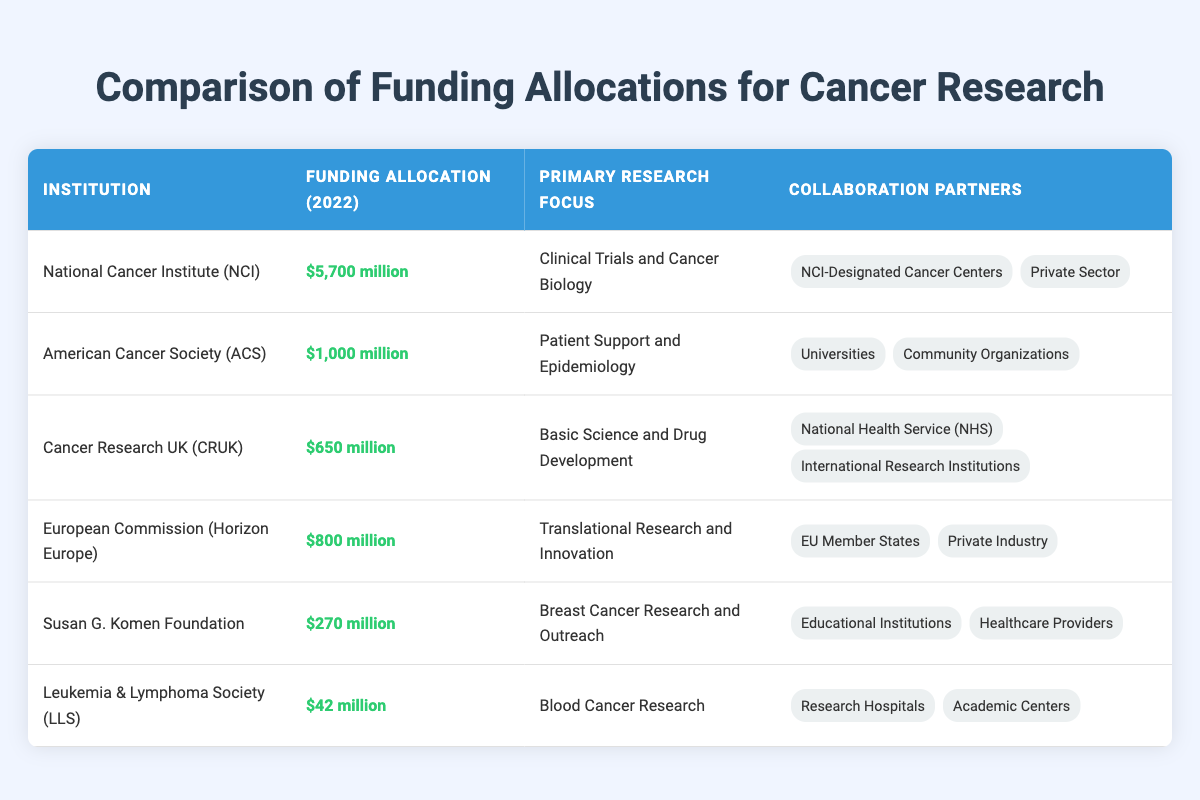What is the highest funding allocation among the institutions? The highest funding allocation can be found by comparing the values in the second column. The National Cancer Institute (NCI) has the highest amount of $5,700 million.
Answer: $5,700 million Which institution focuses on patient support and epidemiology? By looking at the third column of the table, the American Cancer Society (ACS) is listed with a primary research focus on patient support and epidemiology.
Answer: American Cancer Society (ACS) How much funding did Cancer Research UK (CRUK) receive in 2022? The funding allocation for Cancer Research UK (CRUK) is explicitly written in the table under the second column for the 2022 row, which is $650 million.
Answer: $650 million What is the total funding allocated by the National Cancer Institute (NCI) and the American Cancer Society (ACS)? To find the total funding, we need to sum the allocations of both institutions: $5,700 million (NCI) + $1,000 million (ACS) = $6,700 million.
Answer: $6,700 million Is the Susan G. Komen Foundation's research focus related to blood cancer? By referring to the primary research focus listed in the table, the Susan G. Komen Foundation focuses on breast cancer research and outreach, which does not involve blood cancer. Thus, the answer is no.
Answer: No Which institution has the least funding allocation? The least funding allocation can be determined by comparing all values in the funding allocation column. The Leukemia & Lymphoma Society (LLS) has the lowest allocation of $42 million.
Answer: $42 million What is the average funding allocation of all institutions listed? To find the average, sum up all the funding allocations and divide by the number of institutions. The total funding is $5,700 + $1,000 + $650 + $800 + $270 + $42 = $8,462 million. There are 6 institutions, so the average is $8,462 million / 6 = $1,410.33 million.
Answer: $1,410.33 million Do any of the institutions have collaboration with private industry? By reviewing the collaboration partners listed in the table, it shows that the European Commission (Horizon Europe) has private industry as a partner, so the answer is yes.
Answer: Yes How many institutions have a primary research focus in clinical trials and cancer biology? Looking at the table, only one institution has this specific focus, which is the National Cancer Institute (NCI). Therefore, the answer is one institution.
Answer: One institution 